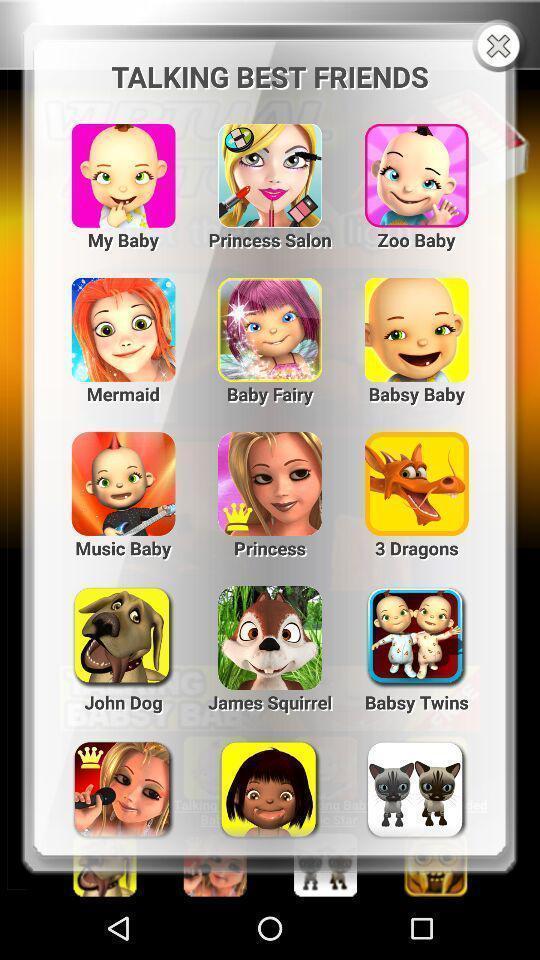Give me a summary of this screen capture. Pop-up screen displaying with list of different animated stickers. 